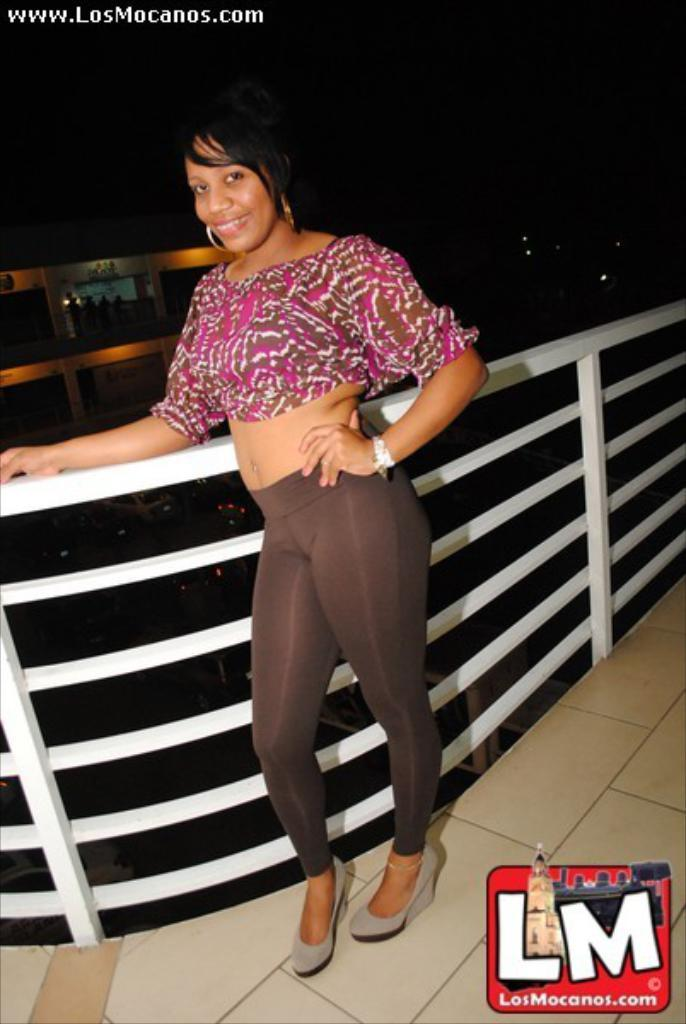What is the main subject of the image? There is a woman standing in the middle of the image. What is the woman's facial expression? The woman is smiling. What can be seen behind the woman? There is fencing visible behind the woman. How would you describe the background of the image? The background of the image is blurred. What type of silver snake is the woman holding in the image? There is no silver snake present in the image. The woman is not holding anything, and there is no mention of a snake in the provided facts. 